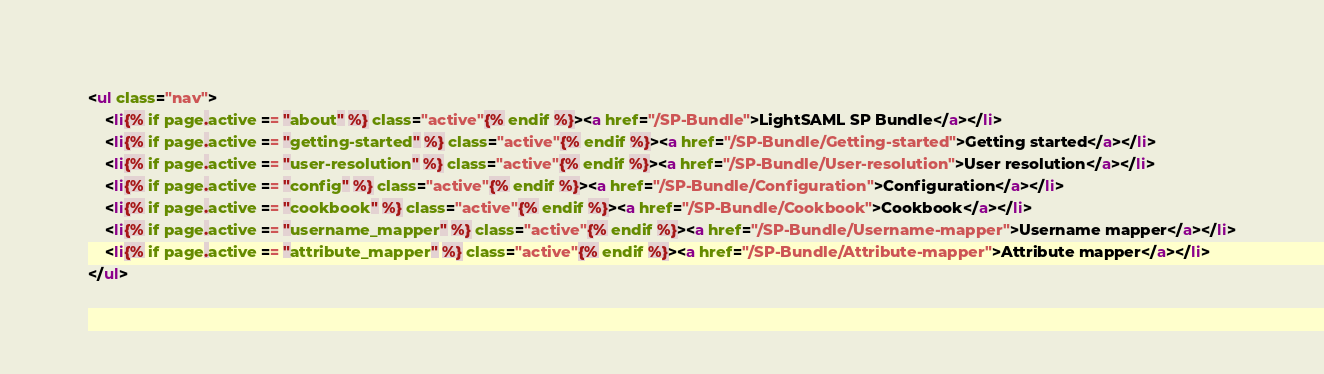Convert code to text. <code><loc_0><loc_0><loc_500><loc_500><_HTML_>
<ul class="nav">
    <li{% if page.active == "about" %} class="active"{% endif %}><a href="/SP-Bundle">LightSAML SP Bundle</a></li>
    <li{% if page.active == "getting-started" %} class="active"{% endif %}><a href="/SP-Bundle/Getting-started">Getting started</a></li>
    <li{% if page.active == "user-resolution" %} class="active"{% endif %}><a href="/SP-Bundle/User-resolution">User resolution</a></li>
    <li{% if page.active == "config" %} class="active"{% endif %}><a href="/SP-Bundle/Configuration">Configuration</a></li>
    <li{% if page.active == "cookbook" %} class="active"{% endif %}><a href="/SP-Bundle/Cookbook">Cookbook</a></li>
    <li{% if page.active == "username_mapper" %} class="active"{% endif %}><a href="/SP-Bundle/Username-mapper">Username mapper</a></li>
    <li{% if page.active == "attribute_mapper" %} class="active"{% endif %}><a href="/SP-Bundle/Attribute-mapper">Attribute mapper</a></li>
</ul>
</code> 